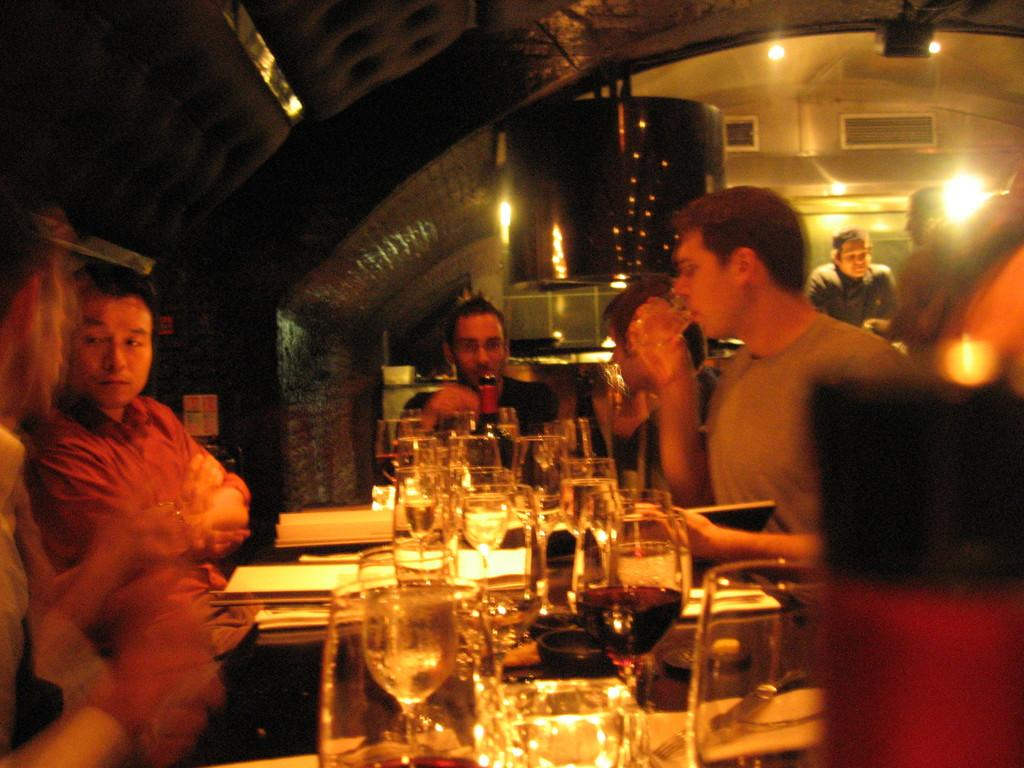How many people are in the image? There is a group of people in the image. What are the people doing in the image? The people are sitting on chairs. What is on the table in the image? There is a glass, a wine bottle, and a paper on the table. What can be seen in the background of the image? There are lights and a wall visible in the background. What type of bear can be seen in the image? There is no bear present in the image. What scientific theory is being discussed by the group of people in the image? The image does not provide any information about a scientific theory being discussed by the group of people. 